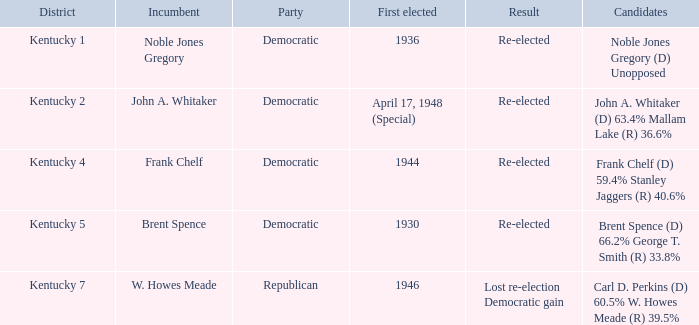How many times was incumbent Noble Jones Gregory first elected? 1.0. 